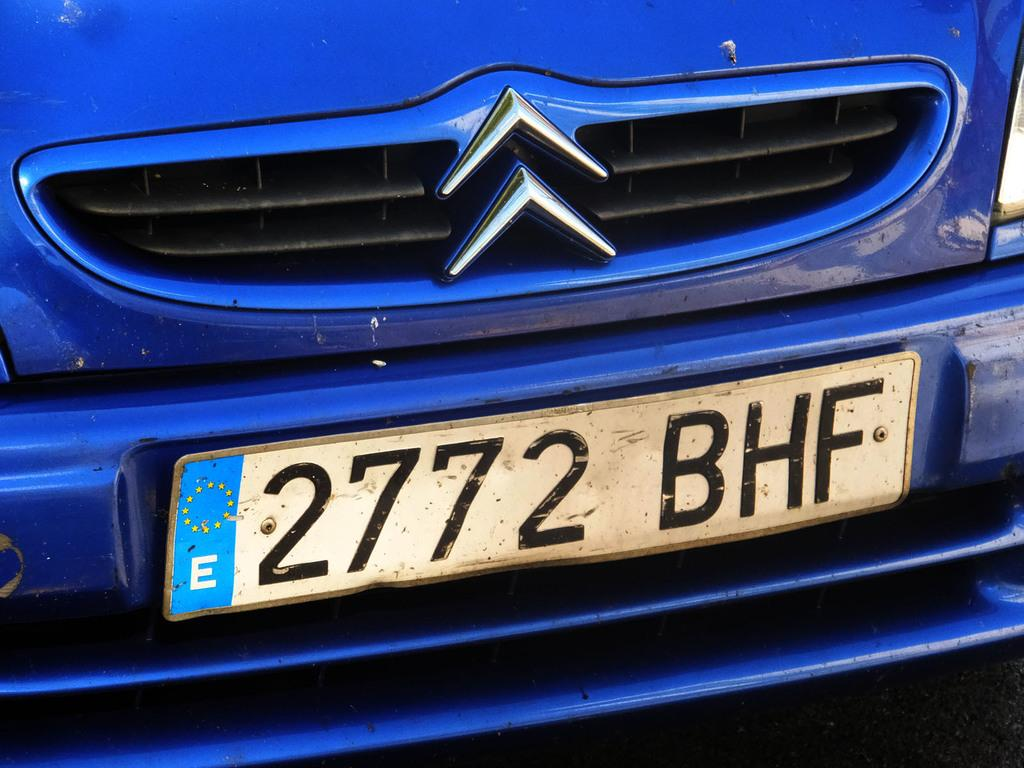What is the main subject of the image? There is a vehicle in the image. Can you describe any specific details about the vehicle? The number plate of the vehicle is visible in the image. What type of tooth can be seen in the image? There is no tooth present in the image; it features a vehicle with a visible number plate. 